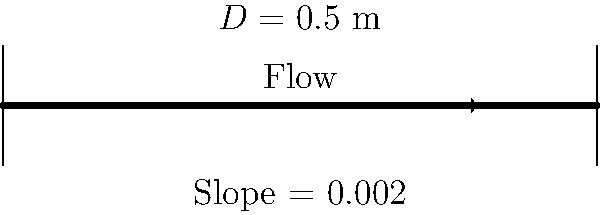In your latest play, you're describing a scene where a character, a civil engineer, is explaining the concept of water flow in pipes to another character. The engineer mentions a circular pipe with a diameter of 0.5 meters and a slope of 0.002. Assuming the pipe is flowing full and the Manning's roughness coefficient is 0.013, what is the flow rate in the pipe in cubic meters per second? Use Manning's equation to calculate the flow rate. To solve this problem, we'll use Manning's equation for full pipe flow:

$$Q = \frac{1}{n} A R^{2/3} S^{1/2}$$

Where:
$Q$ = flow rate (m³/s)
$n$ = Manning's roughness coefficient (0.013)
$A$ = cross-sectional area of the pipe (m²)
$R$ = hydraulic radius (m)
$S$ = slope of the pipe (0.002)

Step 1: Calculate the cross-sectional area (A)
$$A = \frac{\pi D^2}{4} = \frac{\pi (0.5)^2}{4} = 0.1963 \text{ m}^2$$

Step 2: Calculate the wetted perimeter (P)
$$P = \pi D = \pi (0.5) = 1.5708 \text{ m}$$

Step 3: Calculate the hydraulic radius (R)
$$R = \frac{A}{P} = \frac{0.1963}{1.5708} = 0.125 \text{ m}$$

Step 4: Apply Manning's equation
$$Q = \frac{1}{0.013} (0.1963) (0.125)^{2/3} (0.002)^{1/2}$$

Step 5: Calculate the flow rate
$$Q = 0.2725 \text{ m}^3/\text{s}$$
Answer: 0.2725 m³/s 